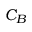Convert formula to latex. <formula><loc_0><loc_0><loc_500><loc_500>C _ { B }</formula> 